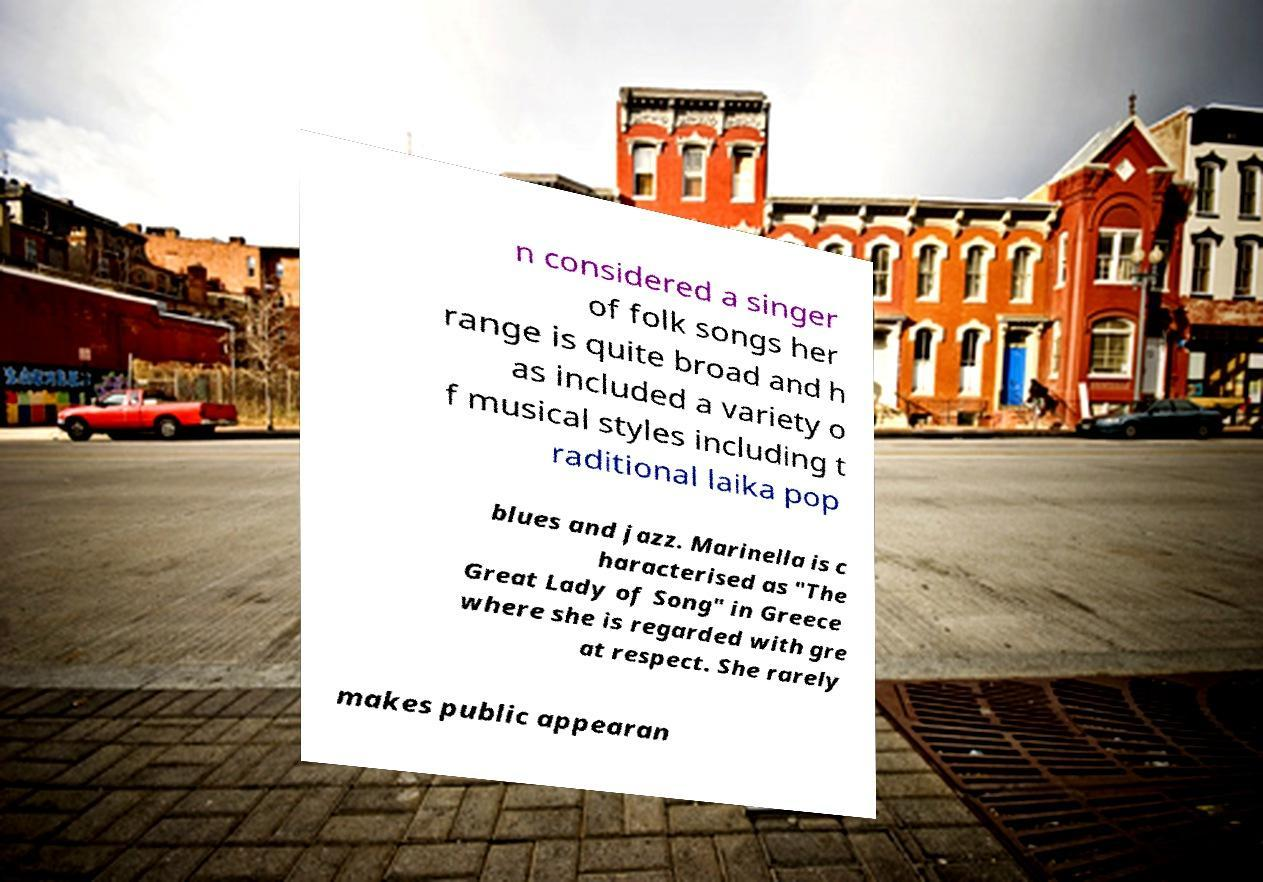Can you read and provide the text displayed in the image?This photo seems to have some interesting text. Can you extract and type it out for me? n considered a singer of folk songs her range is quite broad and h as included a variety o f musical styles including t raditional laika pop blues and jazz. Marinella is c haracterised as "The Great Lady of Song" in Greece where she is regarded with gre at respect. She rarely makes public appearan 